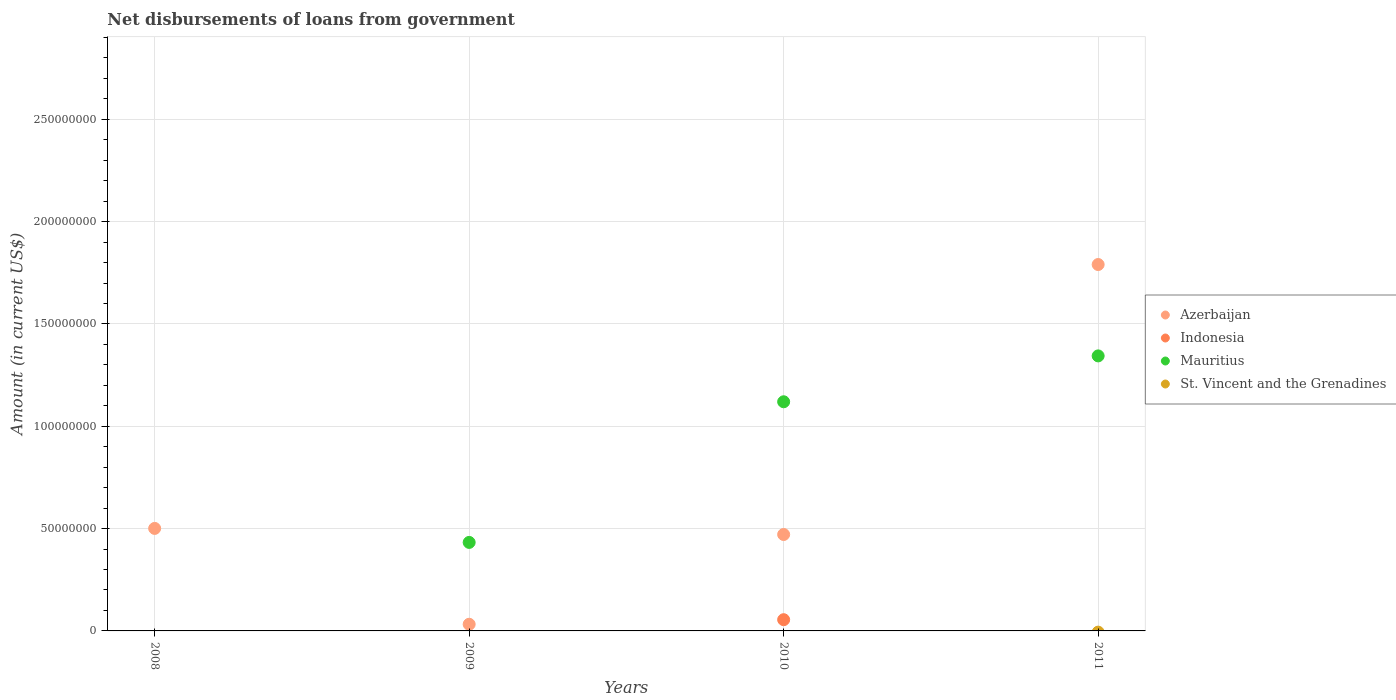Is the number of dotlines equal to the number of legend labels?
Your answer should be very brief. No. What is the amount of loan disbursed from government in Mauritius in 2011?
Your answer should be compact. 1.34e+08. Across all years, what is the maximum amount of loan disbursed from government in Mauritius?
Your answer should be very brief. 1.34e+08. What is the total amount of loan disbursed from government in Indonesia in the graph?
Give a very brief answer. 5.49e+06. What is the difference between the amount of loan disbursed from government in Azerbaijan in 2009 and that in 2011?
Provide a short and direct response. -1.76e+08. What is the difference between the amount of loan disbursed from government in St. Vincent and the Grenadines in 2009 and the amount of loan disbursed from government in Indonesia in 2010?
Your response must be concise. -5.49e+06. What is the average amount of loan disbursed from government in St. Vincent and the Grenadines per year?
Your response must be concise. 0. In the year 2009, what is the difference between the amount of loan disbursed from government in Azerbaijan and amount of loan disbursed from government in Mauritius?
Provide a short and direct response. -4.00e+07. What is the ratio of the amount of loan disbursed from government in Azerbaijan in 2009 to that in 2011?
Give a very brief answer. 0.02. Is the difference between the amount of loan disbursed from government in Azerbaijan in 2009 and 2011 greater than the difference between the amount of loan disbursed from government in Mauritius in 2009 and 2011?
Your response must be concise. No. What is the difference between the highest and the second highest amount of loan disbursed from government in Mauritius?
Provide a succinct answer. 2.24e+07. What is the difference between the highest and the lowest amount of loan disbursed from government in Mauritius?
Keep it short and to the point. 1.34e+08. In how many years, is the amount of loan disbursed from government in Azerbaijan greater than the average amount of loan disbursed from government in Azerbaijan taken over all years?
Your answer should be compact. 1. Is it the case that in every year, the sum of the amount of loan disbursed from government in Indonesia and amount of loan disbursed from government in Azerbaijan  is greater than the sum of amount of loan disbursed from government in Mauritius and amount of loan disbursed from government in St. Vincent and the Grenadines?
Your response must be concise. No. Is it the case that in every year, the sum of the amount of loan disbursed from government in Indonesia and amount of loan disbursed from government in St. Vincent and the Grenadines  is greater than the amount of loan disbursed from government in Azerbaijan?
Give a very brief answer. No. Does the amount of loan disbursed from government in Mauritius monotonically increase over the years?
Keep it short and to the point. Yes. Is the amount of loan disbursed from government in Azerbaijan strictly greater than the amount of loan disbursed from government in Mauritius over the years?
Keep it short and to the point. No. Is the amount of loan disbursed from government in Mauritius strictly less than the amount of loan disbursed from government in Azerbaijan over the years?
Your response must be concise. No. Does the graph contain any zero values?
Offer a terse response. Yes. Does the graph contain grids?
Make the answer very short. Yes. How many legend labels are there?
Keep it short and to the point. 4. What is the title of the graph?
Ensure brevity in your answer.  Net disbursements of loans from government. What is the label or title of the Y-axis?
Provide a short and direct response. Amount (in current US$). What is the Amount (in current US$) in Azerbaijan in 2008?
Your response must be concise. 5.01e+07. What is the Amount (in current US$) of St. Vincent and the Grenadines in 2008?
Offer a terse response. 0. What is the Amount (in current US$) of Azerbaijan in 2009?
Your answer should be very brief. 3.25e+06. What is the Amount (in current US$) of Mauritius in 2009?
Ensure brevity in your answer.  4.32e+07. What is the Amount (in current US$) in Azerbaijan in 2010?
Provide a short and direct response. 4.71e+07. What is the Amount (in current US$) of Indonesia in 2010?
Provide a succinct answer. 5.49e+06. What is the Amount (in current US$) of Mauritius in 2010?
Your response must be concise. 1.12e+08. What is the Amount (in current US$) in Azerbaijan in 2011?
Your answer should be compact. 1.79e+08. What is the Amount (in current US$) in Mauritius in 2011?
Make the answer very short. 1.34e+08. What is the Amount (in current US$) of St. Vincent and the Grenadines in 2011?
Offer a terse response. 0. Across all years, what is the maximum Amount (in current US$) in Azerbaijan?
Keep it short and to the point. 1.79e+08. Across all years, what is the maximum Amount (in current US$) of Indonesia?
Provide a succinct answer. 5.49e+06. Across all years, what is the maximum Amount (in current US$) in Mauritius?
Your answer should be compact. 1.34e+08. Across all years, what is the minimum Amount (in current US$) of Azerbaijan?
Provide a succinct answer. 3.25e+06. Across all years, what is the minimum Amount (in current US$) in Indonesia?
Offer a terse response. 0. Across all years, what is the minimum Amount (in current US$) of Mauritius?
Offer a very short reply. 0. What is the total Amount (in current US$) in Azerbaijan in the graph?
Offer a very short reply. 2.79e+08. What is the total Amount (in current US$) in Indonesia in the graph?
Your response must be concise. 5.49e+06. What is the total Amount (in current US$) of Mauritius in the graph?
Give a very brief answer. 2.90e+08. What is the total Amount (in current US$) of St. Vincent and the Grenadines in the graph?
Offer a very short reply. 0. What is the difference between the Amount (in current US$) of Azerbaijan in 2008 and that in 2009?
Offer a terse response. 4.68e+07. What is the difference between the Amount (in current US$) in Azerbaijan in 2008 and that in 2010?
Make the answer very short. 2.98e+06. What is the difference between the Amount (in current US$) of Azerbaijan in 2008 and that in 2011?
Provide a short and direct response. -1.29e+08. What is the difference between the Amount (in current US$) of Azerbaijan in 2009 and that in 2010?
Offer a terse response. -4.39e+07. What is the difference between the Amount (in current US$) of Mauritius in 2009 and that in 2010?
Keep it short and to the point. -6.87e+07. What is the difference between the Amount (in current US$) of Azerbaijan in 2009 and that in 2011?
Ensure brevity in your answer.  -1.76e+08. What is the difference between the Amount (in current US$) of Mauritius in 2009 and that in 2011?
Your answer should be compact. -9.11e+07. What is the difference between the Amount (in current US$) in Azerbaijan in 2010 and that in 2011?
Offer a very short reply. -1.32e+08. What is the difference between the Amount (in current US$) of Mauritius in 2010 and that in 2011?
Keep it short and to the point. -2.24e+07. What is the difference between the Amount (in current US$) of Azerbaijan in 2008 and the Amount (in current US$) of Mauritius in 2009?
Offer a very short reply. 6.84e+06. What is the difference between the Amount (in current US$) in Azerbaijan in 2008 and the Amount (in current US$) in Indonesia in 2010?
Offer a terse response. 4.46e+07. What is the difference between the Amount (in current US$) of Azerbaijan in 2008 and the Amount (in current US$) of Mauritius in 2010?
Make the answer very short. -6.19e+07. What is the difference between the Amount (in current US$) of Azerbaijan in 2008 and the Amount (in current US$) of Mauritius in 2011?
Your answer should be very brief. -8.43e+07. What is the difference between the Amount (in current US$) in Azerbaijan in 2009 and the Amount (in current US$) in Indonesia in 2010?
Provide a succinct answer. -2.24e+06. What is the difference between the Amount (in current US$) of Azerbaijan in 2009 and the Amount (in current US$) of Mauritius in 2010?
Give a very brief answer. -1.09e+08. What is the difference between the Amount (in current US$) in Azerbaijan in 2009 and the Amount (in current US$) in Mauritius in 2011?
Keep it short and to the point. -1.31e+08. What is the difference between the Amount (in current US$) in Azerbaijan in 2010 and the Amount (in current US$) in Mauritius in 2011?
Your answer should be very brief. -8.73e+07. What is the difference between the Amount (in current US$) in Indonesia in 2010 and the Amount (in current US$) in Mauritius in 2011?
Provide a succinct answer. -1.29e+08. What is the average Amount (in current US$) of Azerbaijan per year?
Offer a very short reply. 6.99e+07. What is the average Amount (in current US$) of Indonesia per year?
Offer a terse response. 1.37e+06. What is the average Amount (in current US$) of Mauritius per year?
Make the answer very short. 7.24e+07. What is the average Amount (in current US$) in St. Vincent and the Grenadines per year?
Keep it short and to the point. 0. In the year 2009, what is the difference between the Amount (in current US$) of Azerbaijan and Amount (in current US$) of Mauritius?
Provide a succinct answer. -4.00e+07. In the year 2010, what is the difference between the Amount (in current US$) in Azerbaijan and Amount (in current US$) in Indonesia?
Make the answer very short. 4.16e+07. In the year 2010, what is the difference between the Amount (in current US$) in Azerbaijan and Amount (in current US$) in Mauritius?
Offer a terse response. -6.49e+07. In the year 2010, what is the difference between the Amount (in current US$) in Indonesia and Amount (in current US$) in Mauritius?
Your answer should be very brief. -1.06e+08. In the year 2011, what is the difference between the Amount (in current US$) in Azerbaijan and Amount (in current US$) in Mauritius?
Provide a succinct answer. 4.46e+07. What is the ratio of the Amount (in current US$) of Azerbaijan in 2008 to that in 2009?
Offer a very short reply. 15.41. What is the ratio of the Amount (in current US$) in Azerbaijan in 2008 to that in 2010?
Provide a short and direct response. 1.06. What is the ratio of the Amount (in current US$) of Azerbaijan in 2008 to that in 2011?
Provide a succinct answer. 0.28. What is the ratio of the Amount (in current US$) of Azerbaijan in 2009 to that in 2010?
Offer a very short reply. 0.07. What is the ratio of the Amount (in current US$) in Mauritius in 2009 to that in 2010?
Your answer should be very brief. 0.39. What is the ratio of the Amount (in current US$) in Azerbaijan in 2009 to that in 2011?
Your answer should be compact. 0.02. What is the ratio of the Amount (in current US$) in Mauritius in 2009 to that in 2011?
Your response must be concise. 0.32. What is the ratio of the Amount (in current US$) of Azerbaijan in 2010 to that in 2011?
Provide a succinct answer. 0.26. What is the ratio of the Amount (in current US$) of Mauritius in 2010 to that in 2011?
Provide a short and direct response. 0.83. What is the difference between the highest and the second highest Amount (in current US$) in Azerbaijan?
Give a very brief answer. 1.29e+08. What is the difference between the highest and the second highest Amount (in current US$) of Mauritius?
Your response must be concise. 2.24e+07. What is the difference between the highest and the lowest Amount (in current US$) in Azerbaijan?
Ensure brevity in your answer.  1.76e+08. What is the difference between the highest and the lowest Amount (in current US$) in Indonesia?
Offer a terse response. 5.49e+06. What is the difference between the highest and the lowest Amount (in current US$) of Mauritius?
Offer a terse response. 1.34e+08. 